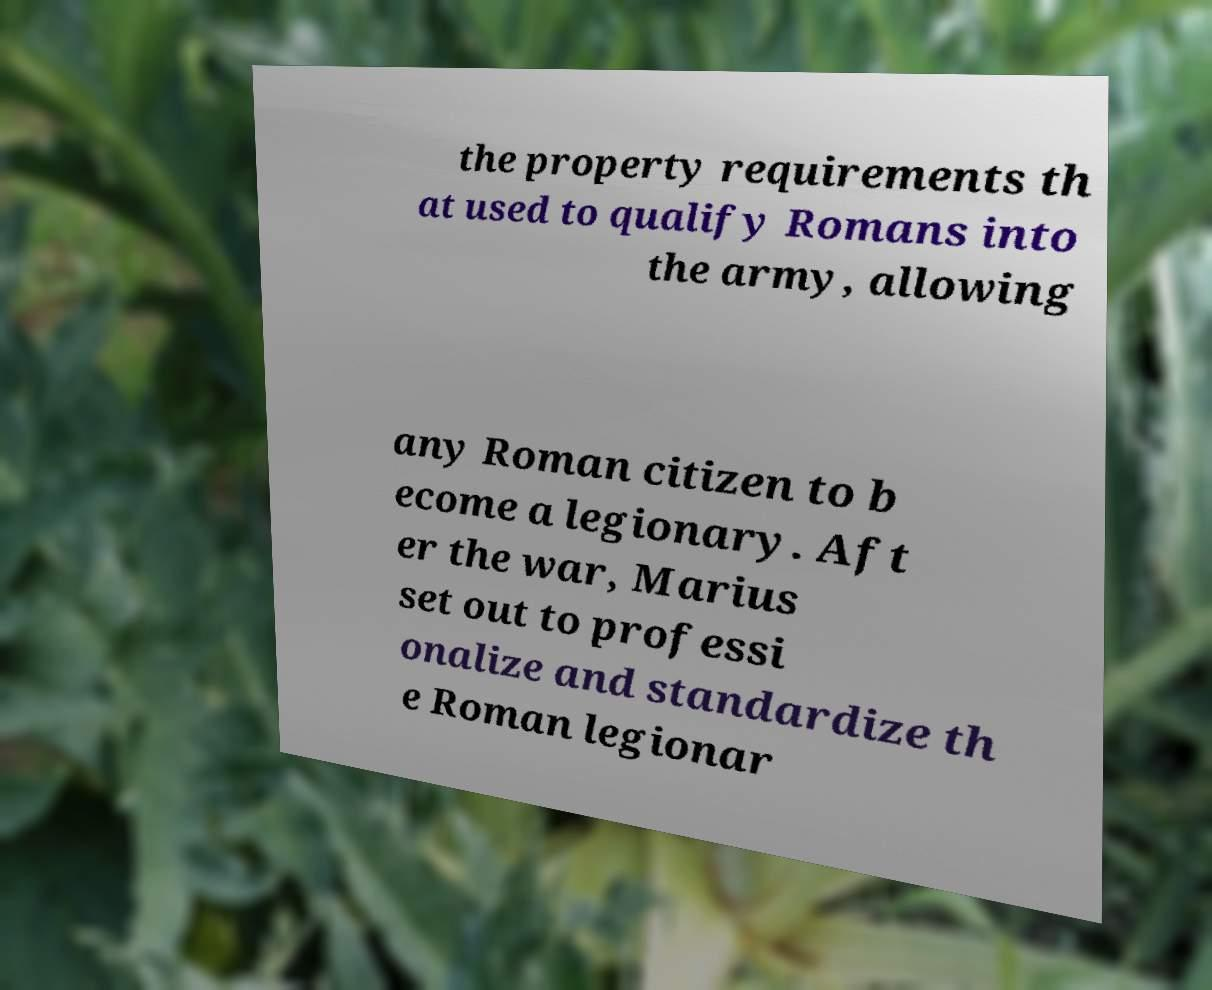There's text embedded in this image that I need extracted. Can you transcribe it verbatim? the property requirements th at used to qualify Romans into the army, allowing any Roman citizen to b ecome a legionary. Aft er the war, Marius set out to professi onalize and standardize th e Roman legionar 